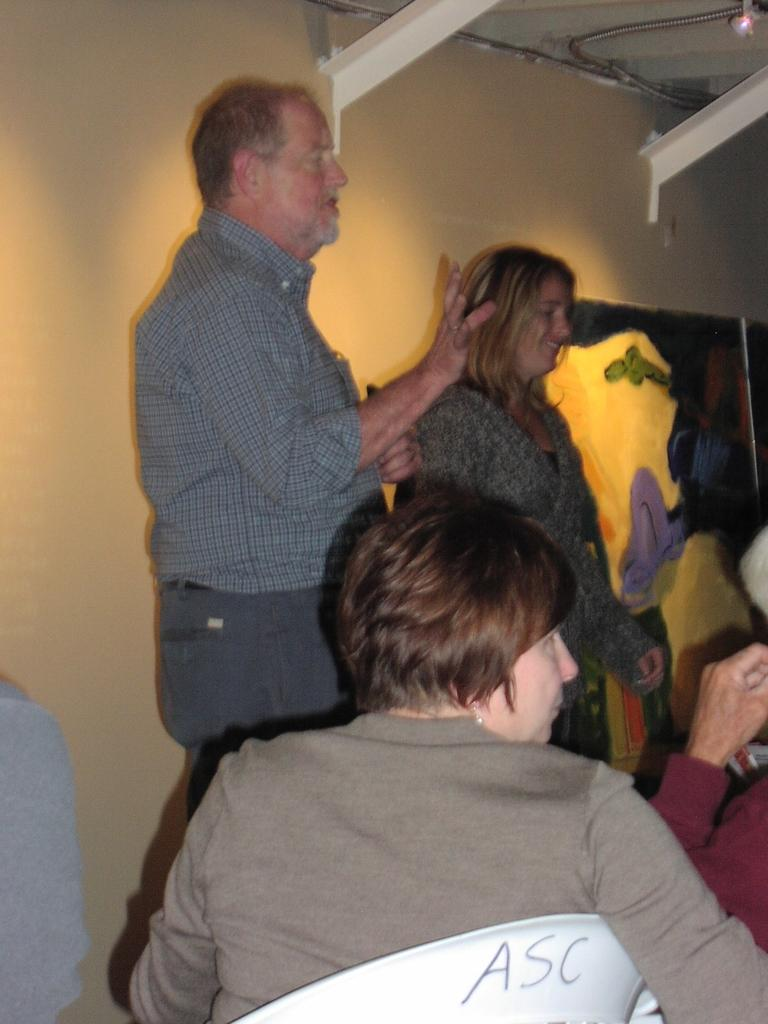How many people are present in the image? There are two people, a man and a woman, present in the image. What are the man and woman doing in the image? The man and woman are standing in the image. Can you describe the seating arrangement in the image? There are people seated on chairs in the image. What can be seen on the wall in the image? There is a painting on the wall in the image. How many deer can be seen in the image? There are no deer present in the image. What type of operation is being performed on the woman in the image? There is no operation being performed on the woman in the image; she is simply standing. 